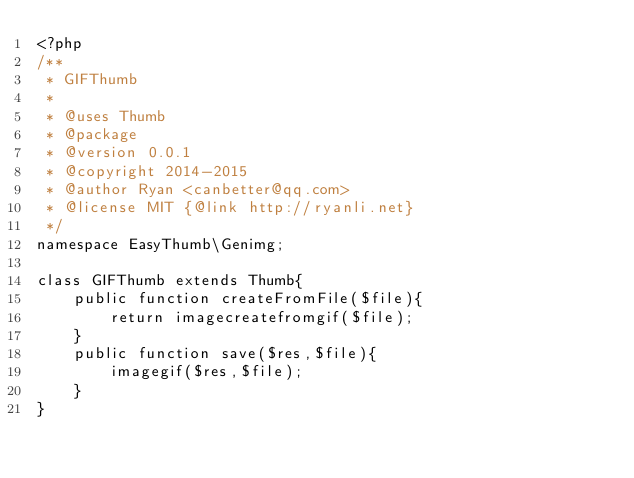Convert code to text. <code><loc_0><loc_0><loc_500><loc_500><_PHP_><?php
/**
 * GIFThumb 
 * 
 * @uses Thumb
 * @package 
 * @version 0.0.1
 * @copyright 2014-2015
 * @author Ryan <canbetter@qq.com> 
 * @license MIT {@link http://ryanli.net}
 */
namespace EasyThumb\Genimg;

class GIFThumb extends Thumb{
    public function createFromFile($file){
        return imagecreatefromgif($file);
    }
    public function save($res,$file){
        imagegif($res,$file);
    }
}
</code> 